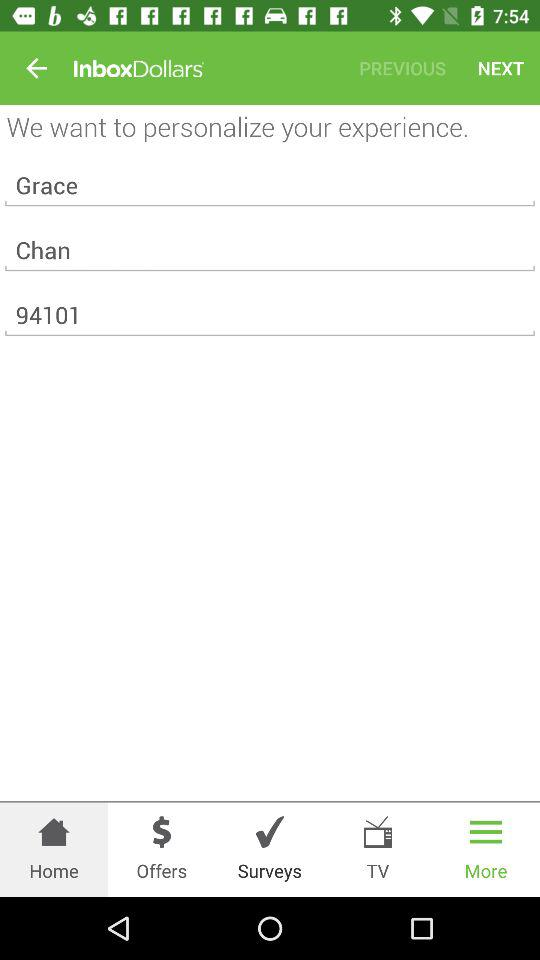How many "InboxDollars" does Grace Chan have on balance?
When the provided information is insufficient, respond with <no answer>. <no answer> 